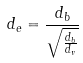<formula> <loc_0><loc_0><loc_500><loc_500>d _ { e } = \frac { d _ { b } } { \sqrt { \frac { d _ { b } } { d _ { v } } } }</formula> 